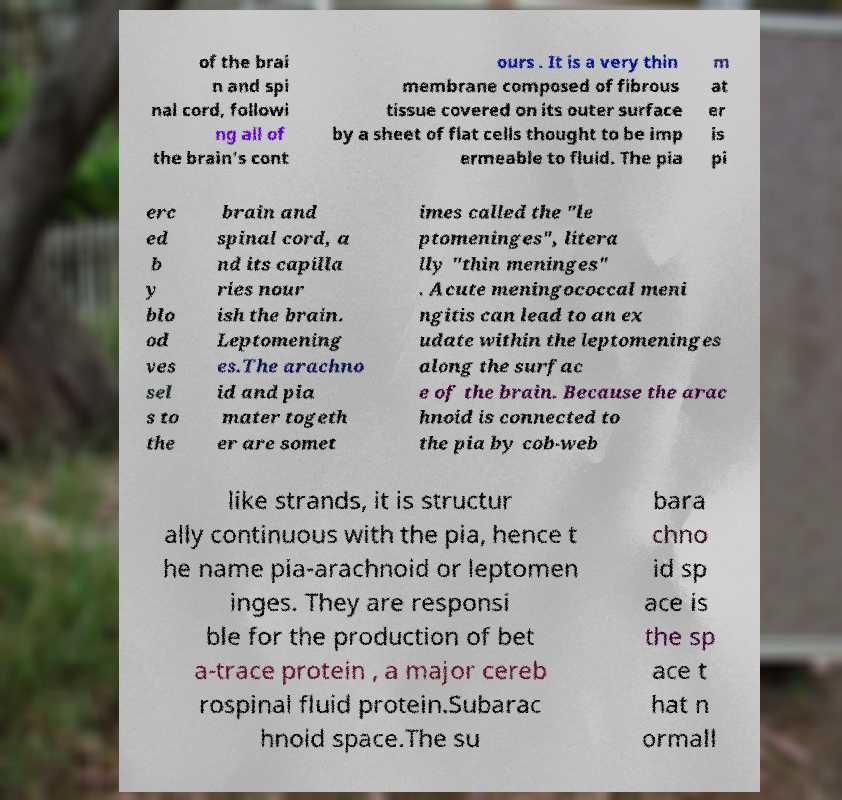Could you assist in decoding the text presented in this image and type it out clearly? of the brai n and spi nal cord, followi ng all of the brain's cont ours . It is a very thin membrane composed of fibrous tissue covered on its outer surface by a sheet of flat cells thought to be imp ermeable to fluid. The pia m at er is pi erc ed b y blo od ves sel s to the brain and spinal cord, a nd its capilla ries nour ish the brain. Leptomening es.The arachno id and pia mater togeth er are somet imes called the "le ptomeninges", litera lly "thin meninges" . Acute meningococcal meni ngitis can lead to an ex udate within the leptomeninges along the surfac e of the brain. Because the arac hnoid is connected to the pia by cob-web like strands, it is structur ally continuous with the pia, hence t he name pia-arachnoid or leptomen inges. They are responsi ble for the production of bet a-trace protein , a major cereb rospinal fluid protein.Subarac hnoid space.The su bara chno id sp ace is the sp ace t hat n ormall 